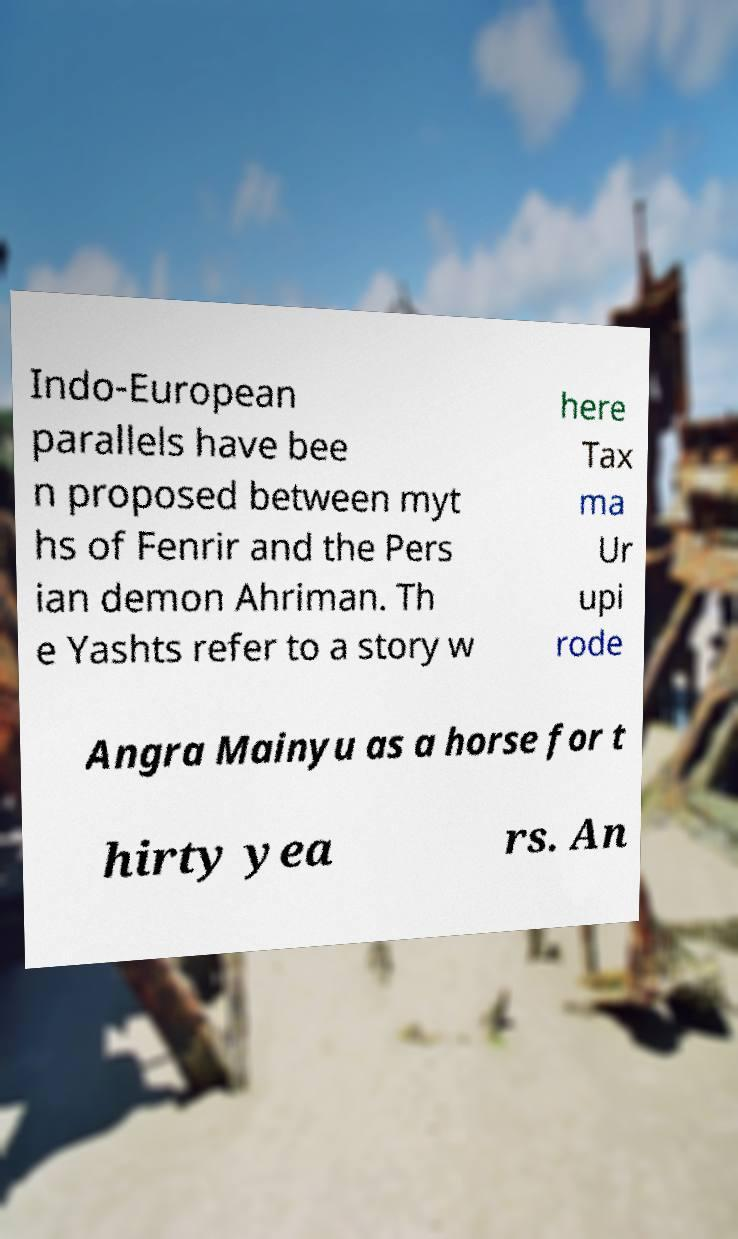Could you extract and type out the text from this image? Indo-European parallels have bee n proposed between myt hs of Fenrir and the Pers ian demon Ahriman. Th e Yashts refer to a story w here Tax ma Ur upi rode Angra Mainyu as a horse for t hirty yea rs. An 